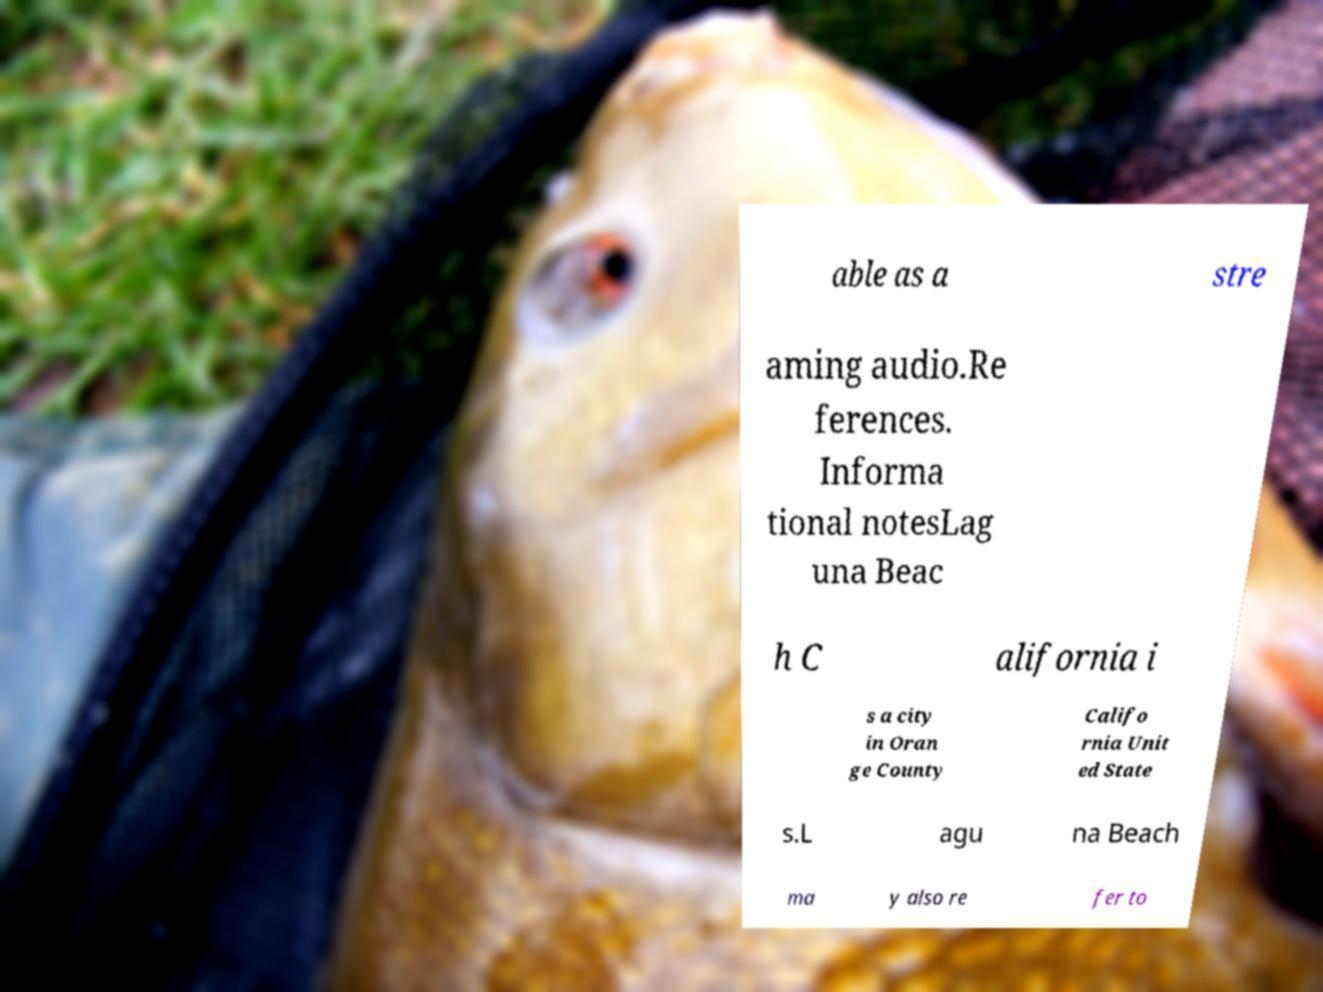Please identify and transcribe the text found in this image. able as a stre aming audio.Re ferences. Informa tional notesLag una Beac h C alifornia i s a city in Oran ge County Califo rnia Unit ed State s.L agu na Beach ma y also re fer to 